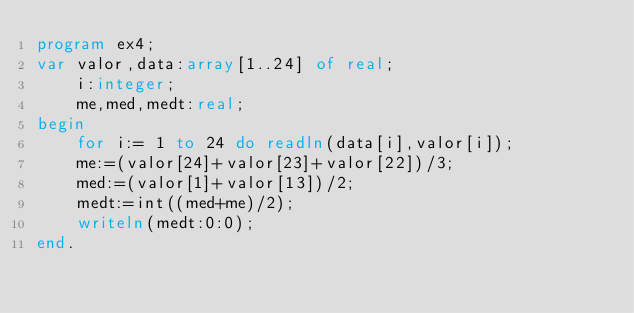Convert code to text. <code><loc_0><loc_0><loc_500><loc_500><_Pascal_>program ex4;
var valor,data:array[1..24] of real;
    i:integer;
    me,med,medt:real;
begin
    for i:= 1 to 24 do readln(data[i],valor[i]);
    me:=(valor[24]+valor[23]+valor[22])/3;
    med:=(valor[1]+valor[13])/2;
    medt:=int((med+me)/2);
    writeln(medt:0:0);
end.
</code> 